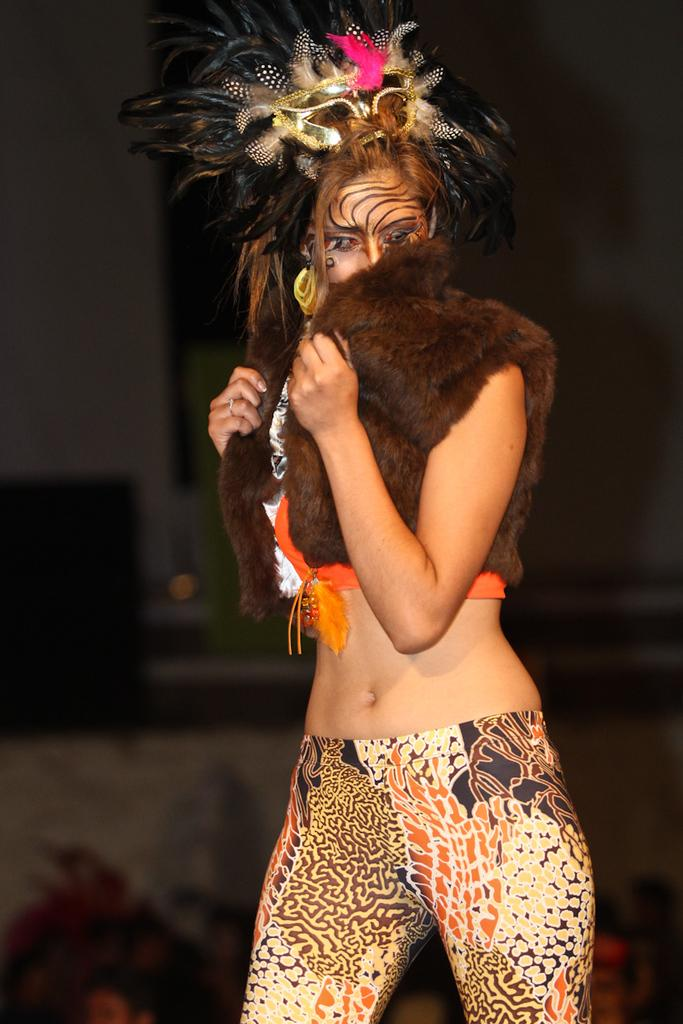Who is the main subject in the image? There is a girl in the center of the image. What is the girl wearing? The girl appears to be wearing a costume. Can you describe the background of the image? The background of the image is blurred. How does the yak contribute to the overall theme of the image? There is no yak present in the image, so it cannot contribute to the overall theme. 